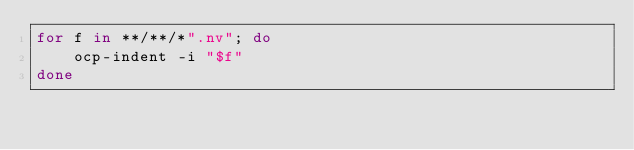<code> <loc_0><loc_0><loc_500><loc_500><_Bash_>for f in **/**/*".nv"; do
    ocp-indent -i "$f"
done
</code> 